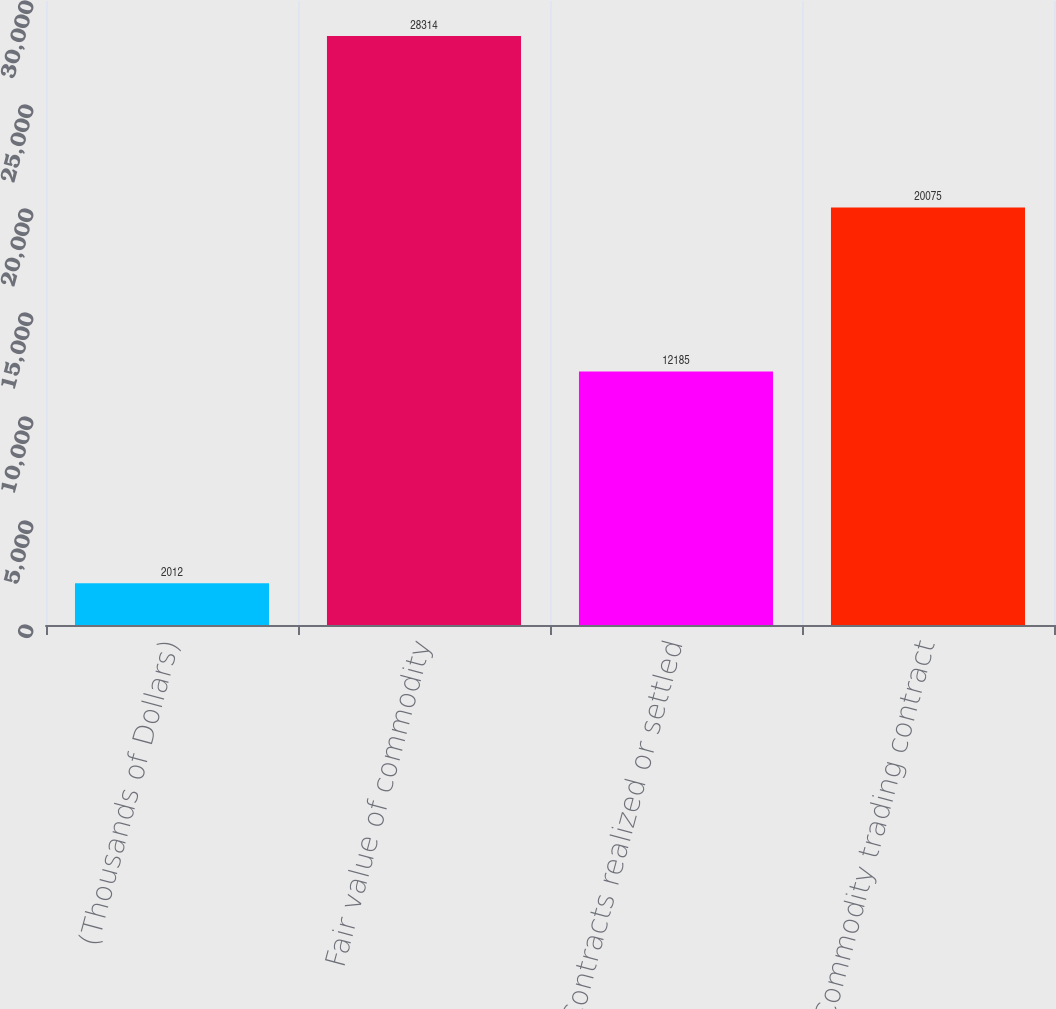<chart> <loc_0><loc_0><loc_500><loc_500><bar_chart><fcel>(Thousands of Dollars)<fcel>Fair value of commodity<fcel>Contracts realized or settled<fcel>Commodity trading contract<nl><fcel>2012<fcel>28314<fcel>12185<fcel>20075<nl></chart> 